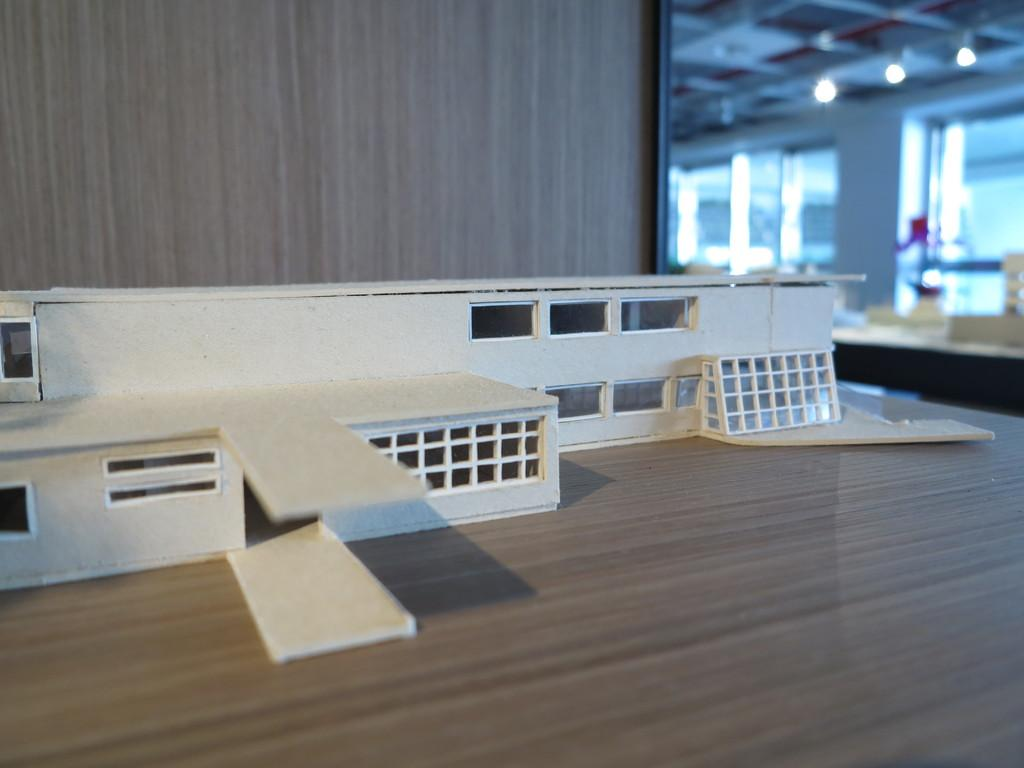What is depicted on the platform in the image? There is a design of a building on the platform. What can be seen in the background of the image? There are lights, a wall, and glasses in the background of the image. What type of tin is being used to hold the ticket in the image? There is no tin or ticket present in the image. What does the caption say about the building design on the platform? There is no caption present in the image; it is a visual representation of the building design on the platform. 